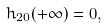Convert formula to latex. <formula><loc_0><loc_0><loc_500><loc_500>h _ { 2 0 } ( + \infty ) = 0 ,</formula> 